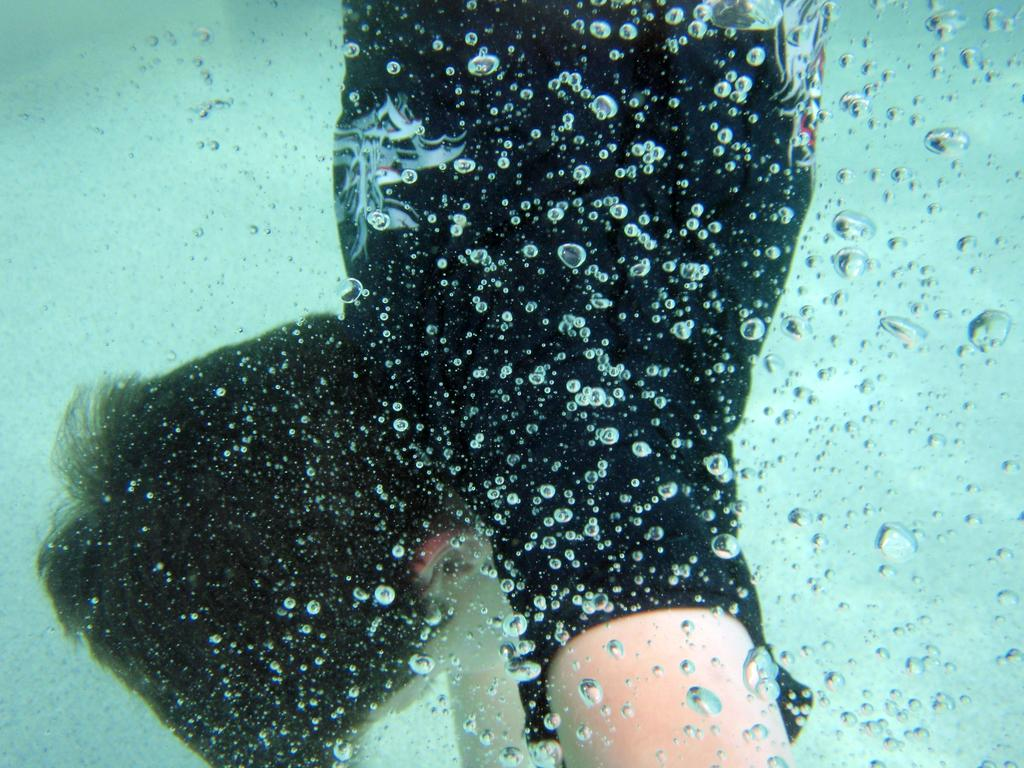Who is present in the image? There is a boy in the image. Where is the boy located? The boy is underwater. What type of shop can be seen in the image? There is no shop present in the image; it features a boy underwater. Can you tell me how the boy is flying in the image? The boy is not flying in the image; he is underwater. 